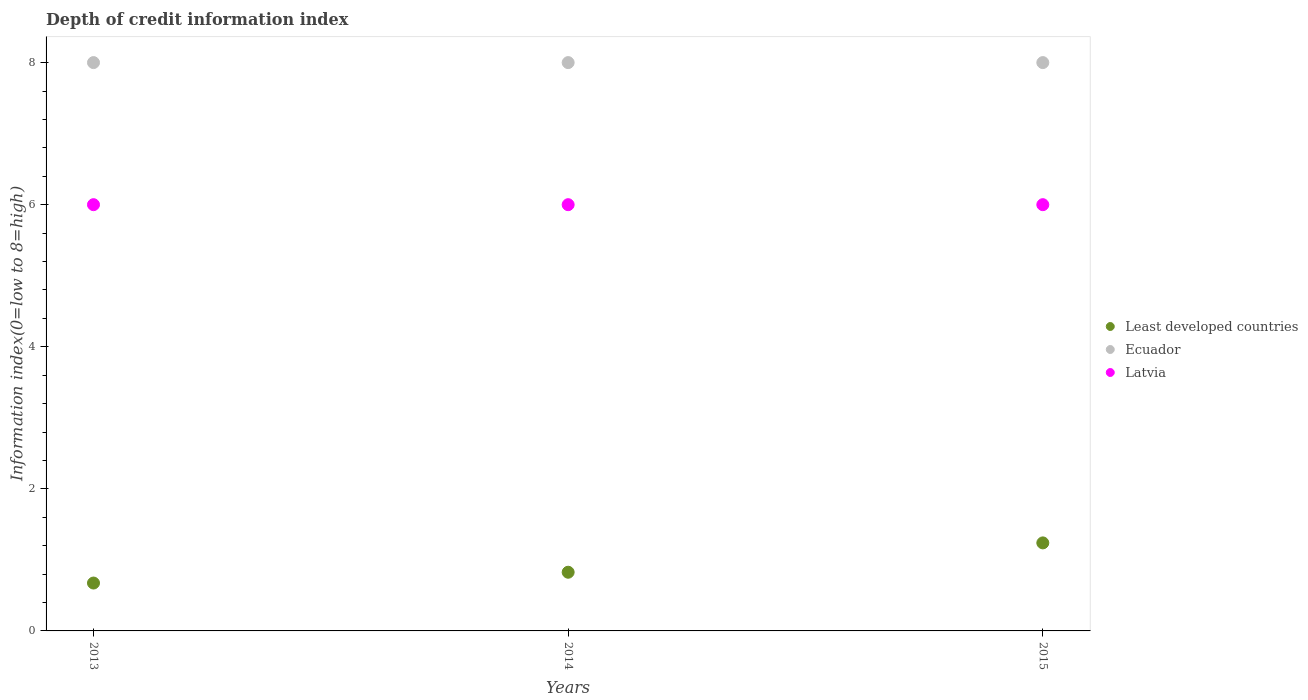How many different coloured dotlines are there?
Give a very brief answer. 3. What is the information index in Least developed countries in 2014?
Provide a succinct answer. 0.83. Across all years, what is the maximum information index in Ecuador?
Your answer should be very brief. 8. In which year was the information index in Latvia minimum?
Offer a terse response. 2013. What is the total information index in Latvia in the graph?
Ensure brevity in your answer.  18. What is the difference between the information index in Ecuador in 2015 and the information index in Latvia in 2013?
Offer a very short reply. 2. In the year 2013, what is the difference between the information index in Least developed countries and information index in Latvia?
Offer a terse response. -5.33. What is the ratio of the information index in Ecuador in 2014 to that in 2015?
Your answer should be very brief. 1. What is the difference between the highest and the lowest information index in Least developed countries?
Keep it short and to the point. 0.57. In how many years, is the information index in Least developed countries greater than the average information index in Least developed countries taken over all years?
Offer a very short reply. 1. Is it the case that in every year, the sum of the information index in Least developed countries and information index in Latvia  is greater than the information index in Ecuador?
Your answer should be very brief. No. Does the information index in Latvia monotonically increase over the years?
Your answer should be compact. No. Is the information index in Ecuador strictly greater than the information index in Latvia over the years?
Offer a very short reply. Yes. Is the information index in Latvia strictly less than the information index in Ecuador over the years?
Your answer should be compact. Yes. What is the difference between two consecutive major ticks on the Y-axis?
Offer a very short reply. 2. Where does the legend appear in the graph?
Keep it short and to the point. Center right. How are the legend labels stacked?
Provide a succinct answer. Vertical. What is the title of the graph?
Ensure brevity in your answer.  Depth of credit information index. What is the label or title of the Y-axis?
Offer a terse response. Information index(0=low to 8=high). What is the Information index(0=low to 8=high) of Least developed countries in 2013?
Your response must be concise. 0.67. What is the Information index(0=low to 8=high) in Ecuador in 2013?
Your response must be concise. 8. What is the Information index(0=low to 8=high) in Latvia in 2013?
Your answer should be compact. 6. What is the Information index(0=low to 8=high) in Least developed countries in 2014?
Your response must be concise. 0.83. What is the Information index(0=low to 8=high) of Latvia in 2014?
Make the answer very short. 6. What is the Information index(0=low to 8=high) of Least developed countries in 2015?
Keep it short and to the point. 1.24. What is the Information index(0=low to 8=high) of Ecuador in 2015?
Provide a short and direct response. 8. What is the Information index(0=low to 8=high) in Latvia in 2015?
Make the answer very short. 6. Across all years, what is the maximum Information index(0=low to 8=high) in Least developed countries?
Provide a succinct answer. 1.24. Across all years, what is the minimum Information index(0=low to 8=high) in Least developed countries?
Your answer should be very brief. 0.67. Across all years, what is the minimum Information index(0=low to 8=high) of Latvia?
Ensure brevity in your answer.  6. What is the total Information index(0=low to 8=high) in Least developed countries in the graph?
Make the answer very short. 2.74. What is the total Information index(0=low to 8=high) in Ecuador in the graph?
Your answer should be very brief. 24. What is the total Information index(0=low to 8=high) in Latvia in the graph?
Offer a very short reply. 18. What is the difference between the Information index(0=low to 8=high) in Least developed countries in 2013 and that in 2014?
Your response must be concise. -0.15. What is the difference between the Information index(0=low to 8=high) in Ecuador in 2013 and that in 2014?
Ensure brevity in your answer.  0. What is the difference between the Information index(0=low to 8=high) of Least developed countries in 2013 and that in 2015?
Offer a very short reply. -0.57. What is the difference between the Information index(0=low to 8=high) in Ecuador in 2013 and that in 2015?
Provide a short and direct response. 0. What is the difference between the Information index(0=low to 8=high) of Latvia in 2013 and that in 2015?
Give a very brief answer. 0. What is the difference between the Information index(0=low to 8=high) in Least developed countries in 2014 and that in 2015?
Provide a short and direct response. -0.41. What is the difference between the Information index(0=low to 8=high) in Latvia in 2014 and that in 2015?
Make the answer very short. 0. What is the difference between the Information index(0=low to 8=high) in Least developed countries in 2013 and the Information index(0=low to 8=high) in Ecuador in 2014?
Keep it short and to the point. -7.33. What is the difference between the Information index(0=low to 8=high) in Least developed countries in 2013 and the Information index(0=low to 8=high) in Latvia in 2014?
Give a very brief answer. -5.33. What is the difference between the Information index(0=low to 8=high) of Least developed countries in 2013 and the Information index(0=low to 8=high) of Ecuador in 2015?
Ensure brevity in your answer.  -7.33. What is the difference between the Information index(0=low to 8=high) in Least developed countries in 2013 and the Information index(0=low to 8=high) in Latvia in 2015?
Your response must be concise. -5.33. What is the difference between the Information index(0=low to 8=high) in Least developed countries in 2014 and the Information index(0=low to 8=high) in Ecuador in 2015?
Your answer should be very brief. -7.17. What is the difference between the Information index(0=low to 8=high) of Least developed countries in 2014 and the Information index(0=low to 8=high) of Latvia in 2015?
Your response must be concise. -5.17. What is the difference between the Information index(0=low to 8=high) in Ecuador in 2014 and the Information index(0=low to 8=high) in Latvia in 2015?
Give a very brief answer. 2. What is the average Information index(0=low to 8=high) of Latvia per year?
Provide a short and direct response. 6. In the year 2013, what is the difference between the Information index(0=low to 8=high) in Least developed countries and Information index(0=low to 8=high) in Ecuador?
Give a very brief answer. -7.33. In the year 2013, what is the difference between the Information index(0=low to 8=high) in Least developed countries and Information index(0=low to 8=high) in Latvia?
Offer a terse response. -5.33. In the year 2013, what is the difference between the Information index(0=low to 8=high) of Ecuador and Information index(0=low to 8=high) of Latvia?
Offer a very short reply. 2. In the year 2014, what is the difference between the Information index(0=low to 8=high) of Least developed countries and Information index(0=low to 8=high) of Ecuador?
Keep it short and to the point. -7.17. In the year 2014, what is the difference between the Information index(0=low to 8=high) of Least developed countries and Information index(0=low to 8=high) of Latvia?
Give a very brief answer. -5.17. In the year 2014, what is the difference between the Information index(0=low to 8=high) of Ecuador and Information index(0=low to 8=high) of Latvia?
Ensure brevity in your answer.  2. In the year 2015, what is the difference between the Information index(0=low to 8=high) in Least developed countries and Information index(0=low to 8=high) in Ecuador?
Make the answer very short. -6.76. In the year 2015, what is the difference between the Information index(0=low to 8=high) of Least developed countries and Information index(0=low to 8=high) of Latvia?
Provide a short and direct response. -4.76. What is the ratio of the Information index(0=low to 8=high) in Least developed countries in 2013 to that in 2014?
Make the answer very short. 0.82. What is the ratio of the Information index(0=low to 8=high) in Latvia in 2013 to that in 2014?
Ensure brevity in your answer.  1. What is the ratio of the Information index(0=low to 8=high) in Least developed countries in 2013 to that in 2015?
Ensure brevity in your answer.  0.54. What is the ratio of the Information index(0=low to 8=high) of Least developed countries in 2014 to that in 2015?
Ensure brevity in your answer.  0.67. What is the ratio of the Information index(0=low to 8=high) of Latvia in 2014 to that in 2015?
Make the answer very short. 1. What is the difference between the highest and the second highest Information index(0=low to 8=high) in Least developed countries?
Offer a very short reply. 0.41. What is the difference between the highest and the second highest Information index(0=low to 8=high) in Ecuador?
Provide a short and direct response. 0. What is the difference between the highest and the second highest Information index(0=low to 8=high) of Latvia?
Provide a succinct answer. 0. What is the difference between the highest and the lowest Information index(0=low to 8=high) in Least developed countries?
Ensure brevity in your answer.  0.57. 